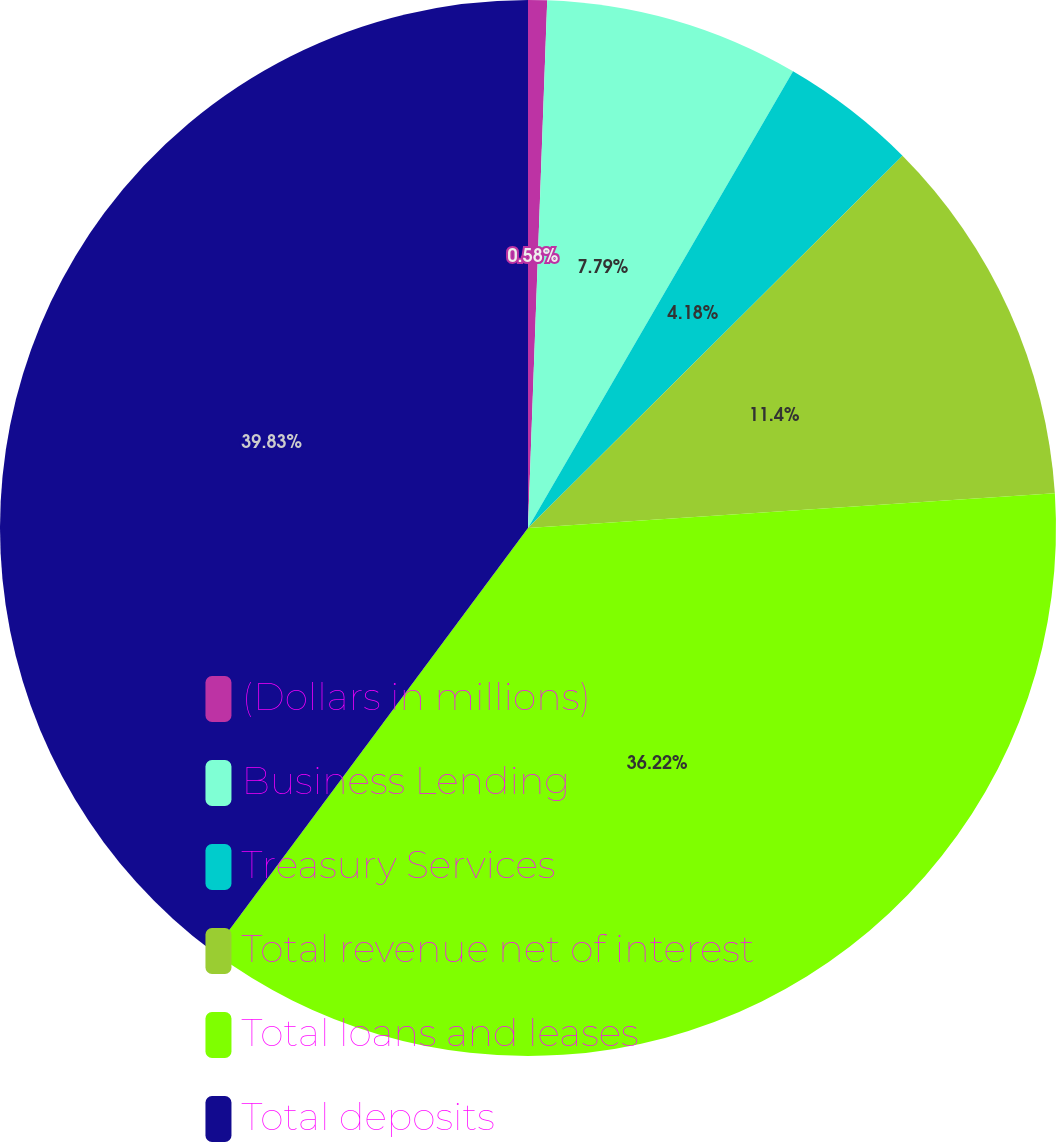Convert chart. <chart><loc_0><loc_0><loc_500><loc_500><pie_chart><fcel>(Dollars in millions)<fcel>Business Lending<fcel>Treasury Services<fcel>Total revenue net of interest<fcel>Total loans and leases<fcel>Total deposits<nl><fcel>0.58%<fcel>7.79%<fcel>4.18%<fcel>11.4%<fcel>36.22%<fcel>39.83%<nl></chart> 